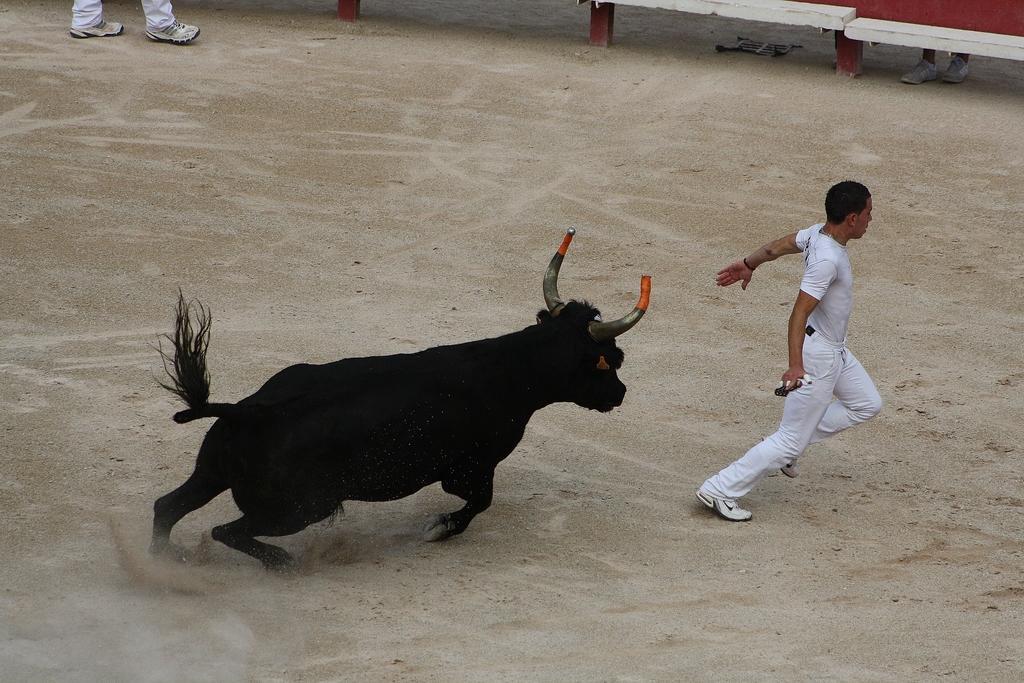How would you summarize this image in a sentence or two? In this image we can see a man holding something in the hand. Near to him there is a bull. At the top we can see legs of persons. On the ground there is sand. 